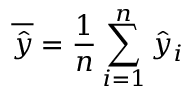<formula> <loc_0><loc_0><loc_500><loc_500>\overline { { \hat { y } } } = \frac { 1 } { n } \sum _ { i = 1 } ^ { n } \hat { y } _ { i }</formula> 